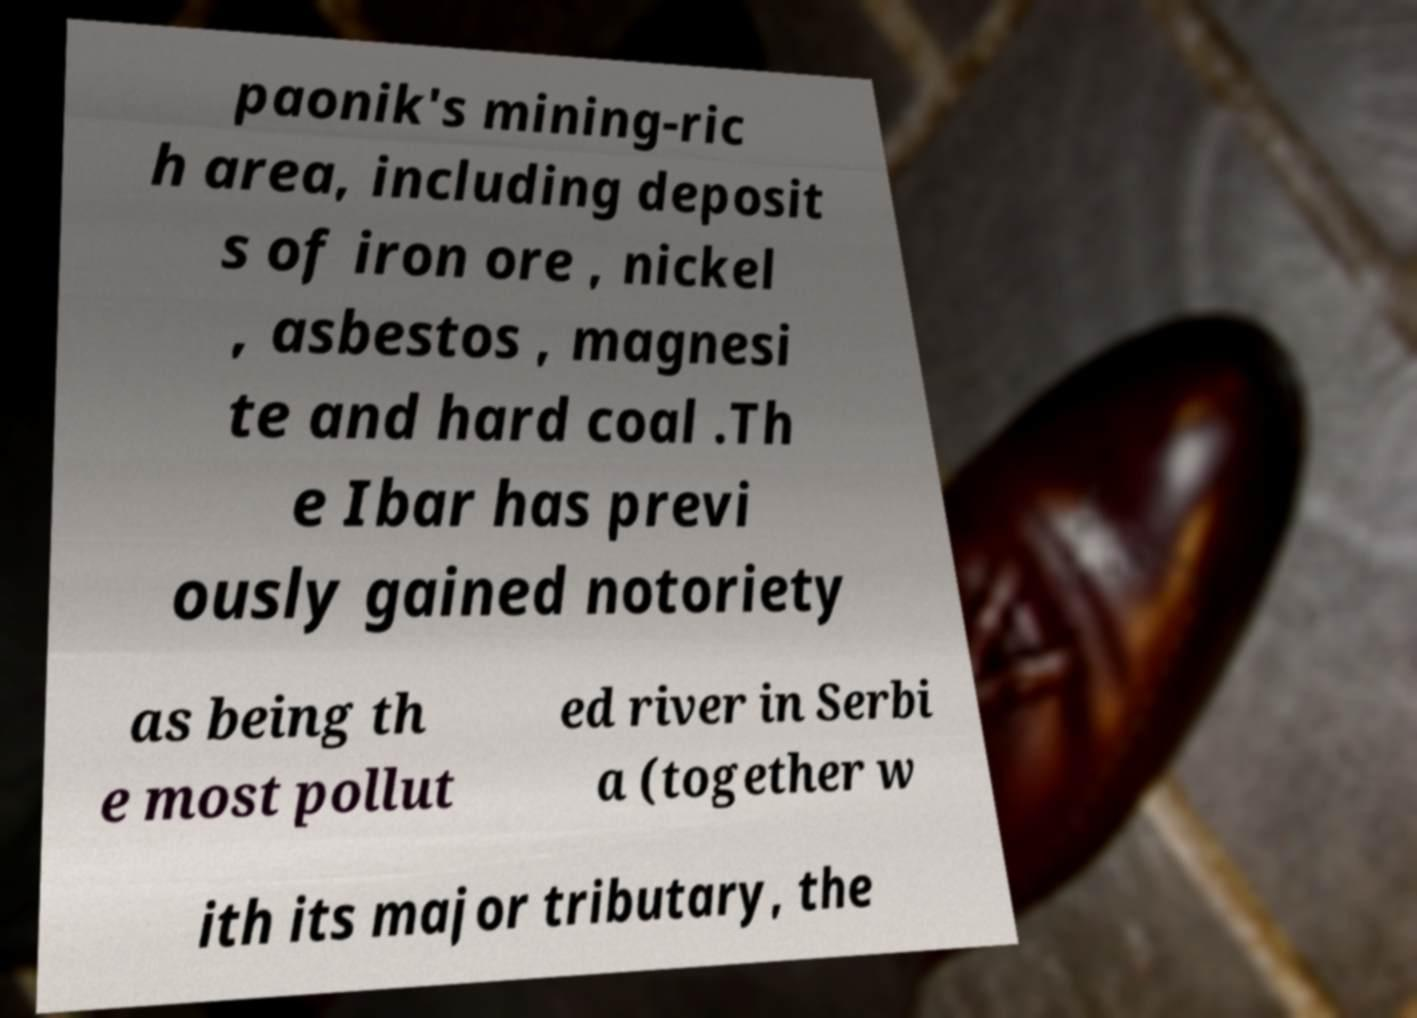Please identify and transcribe the text found in this image. paonik's mining-ric h area, including deposit s of iron ore , nickel , asbestos , magnesi te and hard coal .Th e Ibar has previ ously gained notoriety as being th e most pollut ed river in Serbi a (together w ith its major tributary, the 